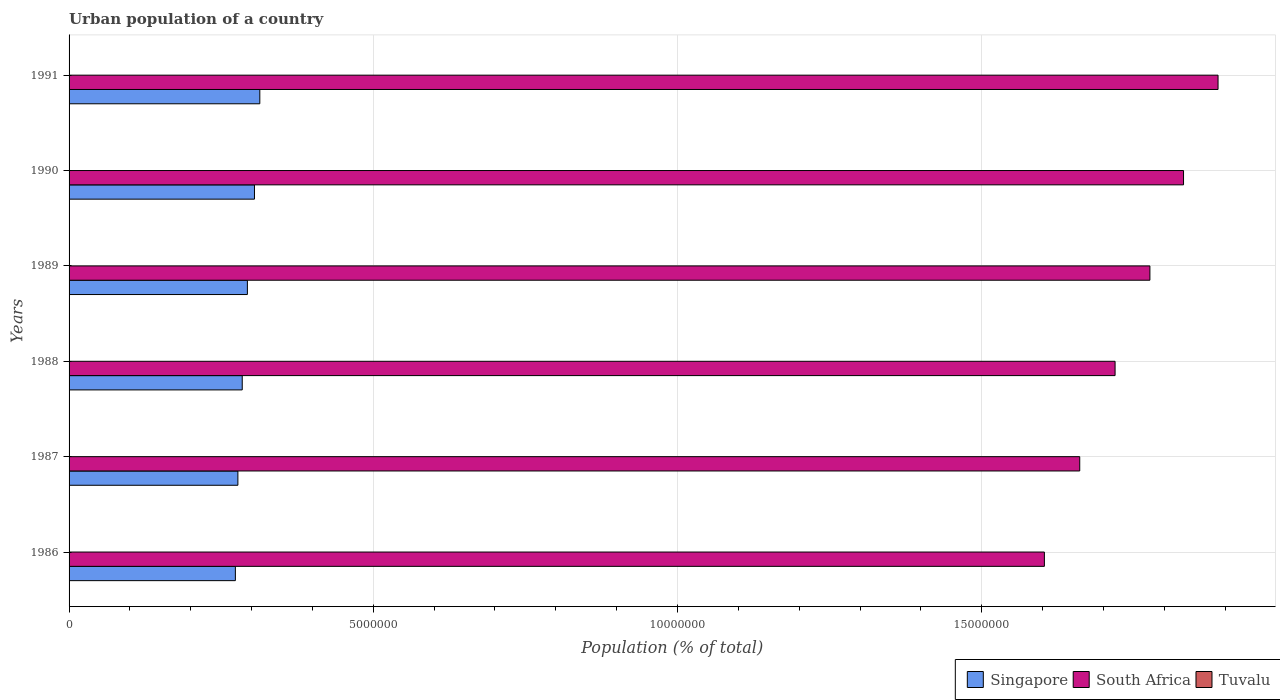How many different coloured bars are there?
Keep it short and to the point. 3. Are the number of bars per tick equal to the number of legend labels?
Keep it short and to the point. Yes. Are the number of bars on each tick of the Y-axis equal?
Your answer should be compact. Yes. How many bars are there on the 2nd tick from the top?
Ensure brevity in your answer.  3. What is the label of the 4th group of bars from the top?
Provide a succinct answer. 1988. In how many cases, is the number of bars for a given year not equal to the number of legend labels?
Give a very brief answer. 0. What is the urban population in South Africa in 1986?
Provide a short and direct response. 1.60e+07. Across all years, what is the maximum urban population in Tuvalu?
Keep it short and to the point. 3803. Across all years, what is the minimum urban population in Tuvalu?
Offer a very short reply. 3103. What is the total urban population in Singapore in the graph?
Provide a succinct answer. 1.75e+07. What is the difference between the urban population in Singapore in 1986 and that in 1987?
Keep it short and to the point. -4.14e+04. What is the difference between the urban population in Singapore in 1987 and the urban population in Tuvalu in 1989?
Provide a succinct answer. 2.77e+06. What is the average urban population in South Africa per year?
Your response must be concise. 1.75e+07. In the year 1986, what is the difference between the urban population in Tuvalu and urban population in South Africa?
Provide a succinct answer. -1.60e+07. What is the ratio of the urban population in South Africa in 1987 to that in 1991?
Give a very brief answer. 0.88. Is the difference between the urban population in Tuvalu in 1986 and 1990 greater than the difference between the urban population in South Africa in 1986 and 1990?
Provide a succinct answer. Yes. What is the difference between the highest and the second highest urban population in South Africa?
Give a very brief answer. 5.67e+05. What is the difference between the highest and the lowest urban population in Tuvalu?
Provide a short and direct response. 700. In how many years, is the urban population in South Africa greater than the average urban population in South Africa taken over all years?
Your answer should be very brief. 3. What does the 1st bar from the top in 1987 represents?
Ensure brevity in your answer.  Tuvalu. What does the 1st bar from the bottom in 1990 represents?
Offer a very short reply. Singapore. How many bars are there?
Ensure brevity in your answer.  18. How many years are there in the graph?
Provide a succinct answer. 6. What is the difference between two consecutive major ticks on the X-axis?
Provide a succinct answer. 5.00e+06. Are the values on the major ticks of X-axis written in scientific E-notation?
Give a very brief answer. No. Where does the legend appear in the graph?
Provide a short and direct response. Bottom right. How are the legend labels stacked?
Keep it short and to the point. Horizontal. What is the title of the graph?
Your response must be concise. Urban population of a country. What is the label or title of the X-axis?
Provide a short and direct response. Population (% of total). What is the Population (% of total) in Singapore in 1986?
Your answer should be compact. 2.73e+06. What is the Population (% of total) of South Africa in 1986?
Your answer should be very brief. 1.60e+07. What is the Population (% of total) of Tuvalu in 1986?
Give a very brief answer. 3103. What is the Population (% of total) of Singapore in 1987?
Provide a succinct answer. 2.77e+06. What is the Population (% of total) in South Africa in 1987?
Offer a very short reply. 1.66e+07. What is the Population (% of total) of Tuvalu in 1987?
Offer a very short reply. 3243. What is the Population (% of total) in Singapore in 1988?
Ensure brevity in your answer.  2.85e+06. What is the Population (% of total) in South Africa in 1988?
Give a very brief answer. 1.72e+07. What is the Population (% of total) in Tuvalu in 1988?
Your answer should be compact. 3382. What is the Population (% of total) in Singapore in 1989?
Keep it short and to the point. 2.93e+06. What is the Population (% of total) in South Africa in 1989?
Your response must be concise. 1.78e+07. What is the Population (% of total) in Tuvalu in 1989?
Ensure brevity in your answer.  3521. What is the Population (% of total) of Singapore in 1990?
Keep it short and to the point. 3.05e+06. What is the Population (% of total) of South Africa in 1990?
Provide a short and direct response. 1.83e+07. What is the Population (% of total) in Tuvalu in 1990?
Make the answer very short. 3661. What is the Population (% of total) of Singapore in 1991?
Keep it short and to the point. 3.14e+06. What is the Population (% of total) in South Africa in 1991?
Make the answer very short. 1.89e+07. What is the Population (% of total) in Tuvalu in 1991?
Provide a short and direct response. 3803. Across all years, what is the maximum Population (% of total) in Singapore?
Make the answer very short. 3.14e+06. Across all years, what is the maximum Population (% of total) in South Africa?
Provide a succinct answer. 1.89e+07. Across all years, what is the maximum Population (% of total) of Tuvalu?
Give a very brief answer. 3803. Across all years, what is the minimum Population (% of total) in Singapore?
Ensure brevity in your answer.  2.73e+06. Across all years, what is the minimum Population (% of total) of South Africa?
Ensure brevity in your answer.  1.60e+07. Across all years, what is the minimum Population (% of total) of Tuvalu?
Provide a short and direct response. 3103. What is the total Population (% of total) of Singapore in the graph?
Your answer should be very brief. 1.75e+07. What is the total Population (% of total) in South Africa in the graph?
Give a very brief answer. 1.05e+08. What is the total Population (% of total) in Tuvalu in the graph?
Your answer should be very brief. 2.07e+04. What is the difference between the Population (% of total) in Singapore in 1986 and that in 1987?
Provide a succinct answer. -4.14e+04. What is the difference between the Population (% of total) in South Africa in 1986 and that in 1987?
Give a very brief answer. -5.81e+05. What is the difference between the Population (% of total) of Tuvalu in 1986 and that in 1987?
Offer a terse response. -140. What is the difference between the Population (% of total) in Singapore in 1986 and that in 1988?
Make the answer very short. -1.13e+05. What is the difference between the Population (% of total) in South Africa in 1986 and that in 1988?
Your answer should be compact. -1.16e+06. What is the difference between the Population (% of total) of Tuvalu in 1986 and that in 1988?
Ensure brevity in your answer.  -279. What is the difference between the Population (% of total) in Singapore in 1986 and that in 1989?
Your answer should be compact. -1.98e+05. What is the difference between the Population (% of total) in South Africa in 1986 and that in 1989?
Ensure brevity in your answer.  -1.73e+06. What is the difference between the Population (% of total) of Tuvalu in 1986 and that in 1989?
Give a very brief answer. -418. What is the difference between the Population (% of total) of Singapore in 1986 and that in 1990?
Make the answer very short. -3.14e+05. What is the difference between the Population (% of total) of South Africa in 1986 and that in 1990?
Ensure brevity in your answer.  -2.29e+06. What is the difference between the Population (% of total) of Tuvalu in 1986 and that in 1990?
Your response must be concise. -558. What is the difference between the Population (% of total) in Singapore in 1986 and that in 1991?
Your answer should be compact. -4.02e+05. What is the difference between the Population (% of total) in South Africa in 1986 and that in 1991?
Your answer should be compact. -2.85e+06. What is the difference between the Population (% of total) of Tuvalu in 1986 and that in 1991?
Make the answer very short. -700. What is the difference between the Population (% of total) of Singapore in 1987 and that in 1988?
Provide a succinct answer. -7.13e+04. What is the difference between the Population (% of total) in South Africa in 1987 and that in 1988?
Provide a succinct answer. -5.81e+05. What is the difference between the Population (% of total) of Tuvalu in 1987 and that in 1988?
Provide a succinct answer. -139. What is the difference between the Population (% of total) in Singapore in 1987 and that in 1989?
Your answer should be very brief. -1.56e+05. What is the difference between the Population (% of total) of South Africa in 1987 and that in 1989?
Provide a succinct answer. -1.15e+06. What is the difference between the Population (% of total) of Tuvalu in 1987 and that in 1989?
Keep it short and to the point. -278. What is the difference between the Population (% of total) of Singapore in 1987 and that in 1990?
Give a very brief answer. -2.72e+05. What is the difference between the Population (% of total) of South Africa in 1987 and that in 1990?
Offer a terse response. -1.71e+06. What is the difference between the Population (% of total) of Tuvalu in 1987 and that in 1990?
Your answer should be compact. -418. What is the difference between the Population (% of total) in Singapore in 1987 and that in 1991?
Ensure brevity in your answer.  -3.60e+05. What is the difference between the Population (% of total) in South Africa in 1987 and that in 1991?
Ensure brevity in your answer.  -2.27e+06. What is the difference between the Population (% of total) in Tuvalu in 1987 and that in 1991?
Give a very brief answer. -560. What is the difference between the Population (% of total) of Singapore in 1988 and that in 1989?
Ensure brevity in your answer.  -8.48e+04. What is the difference between the Population (% of total) of South Africa in 1988 and that in 1989?
Provide a succinct answer. -5.72e+05. What is the difference between the Population (% of total) of Tuvalu in 1988 and that in 1989?
Offer a very short reply. -139. What is the difference between the Population (% of total) of Singapore in 1988 and that in 1990?
Offer a very short reply. -2.01e+05. What is the difference between the Population (% of total) in South Africa in 1988 and that in 1990?
Your answer should be compact. -1.12e+06. What is the difference between the Population (% of total) in Tuvalu in 1988 and that in 1990?
Give a very brief answer. -279. What is the difference between the Population (% of total) of Singapore in 1988 and that in 1991?
Offer a terse response. -2.89e+05. What is the difference between the Population (% of total) of South Africa in 1988 and that in 1991?
Your answer should be very brief. -1.69e+06. What is the difference between the Population (% of total) in Tuvalu in 1988 and that in 1991?
Offer a terse response. -421. What is the difference between the Population (% of total) in Singapore in 1989 and that in 1990?
Ensure brevity in your answer.  -1.16e+05. What is the difference between the Population (% of total) of South Africa in 1989 and that in 1990?
Provide a short and direct response. -5.53e+05. What is the difference between the Population (% of total) of Tuvalu in 1989 and that in 1990?
Provide a succinct answer. -140. What is the difference between the Population (% of total) of Singapore in 1989 and that in 1991?
Offer a terse response. -2.04e+05. What is the difference between the Population (% of total) of South Africa in 1989 and that in 1991?
Offer a very short reply. -1.12e+06. What is the difference between the Population (% of total) of Tuvalu in 1989 and that in 1991?
Ensure brevity in your answer.  -282. What is the difference between the Population (% of total) in Singapore in 1990 and that in 1991?
Your response must be concise. -8.80e+04. What is the difference between the Population (% of total) in South Africa in 1990 and that in 1991?
Keep it short and to the point. -5.67e+05. What is the difference between the Population (% of total) in Tuvalu in 1990 and that in 1991?
Your answer should be compact. -142. What is the difference between the Population (% of total) of Singapore in 1986 and the Population (% of total) of South Africa in 1987?
Provide a short and direct response. -1.39e+07. What is the difference between the Population (% of total) in Singapore in 1986 and the Population (% of total) in Tuvalu in 1987?
Provide a short and direct response. 2.73e+06. What is the difference between the Population (% of total) of South Africa in 1986 and the Population (% of total) of Tuvalu in 1987?
Your answer should be compact. 1.60e+07. What is the difference between the Population (% of total) of Singapore in 1986 and the Population (% of total) of South Africa in 1988?
Make the answer very short. -1.45e+07. What is the difference between the Population (% of total) of Singapore in 1986 and the Population (% of total) of Tuvalu in 1988?
Ensure brevity in your answer.  2.73e+06. What is the difference between the Population (% of total) of South Africa in 1986 and the Population (% of total) of Tuvalu in 1988?
Offer a terse response. 1.60e+07. What is the difference between the Population (% of total) of Singapore in 1986 and the Population (% of total) of South Africa in 1989?
Provide a short and direct response. -1.50e+07. What is the difference between the Population (% of total) of Singapore in 1986 and the Population (% of total) of Tuvalu in 1989?
Your answer should be compact. 2.73e+06. What is the difference between the Population (% of total) in South Africa in 1986 and the Population (% of total) in Tuvalu in 1989?
Give a very brief answer. 1.60e+07. What is the difference between the Population (% of total) in Singapore in 1986 and the Population (% of total) in South Africa in 1990?
Your response must be concise. -1.56e+07. What is the difference between the Population (% of total) in Singapore in 1986 and the Population (% of total) in Tuvalu in 1990?
Keep it short and to the point. 2.73e+06. What is the difference between the Population (% of total) of South Africa in 1986 and the Population (% of total) of Tuvalu in 1990?
Provide a succinct answer. 1.60e+07. What is the difference between the Population (% of total) in Singapore in 1986 and the Population (% of total) in South Africa in 1991?
Offer a very short reply. -1.62e+07. What is the difference between the Population (% of total) in Singapore in 1986 and the Population (% of total) in Tuvalu in 1991?
Provide a short and direct response. 2.73e+06. What is the difference between the Population (% of total) in South Africa in 1986 and the Population (% of total) in Tuvalu in 1991?
Offer a terse response. 1.60e+07. What is the difference between the Population (% of total) in Singapore in 1987 and the Population (% of total) in South Africa in 1988?
Give a very brief answer. -1.44e+07. What is the difference between the Population (% of total) of Singapore in 1987 and the Population (% of total) of Tuvalu in 1988?
Your answer should be very brief. 2.77e+06. What is the difference between the Population (% of total) of South Africa in 1987 and the Population (% of total) of Tuvalu in 1988?
Your response must be concise. 1.66e+07. What is the difference between the Population (% of total) in Singapore in 1987 and the Population (% of total) in South Africa in 1989?
Your answer should be compact. -1.50e+07. What is the difference between the Population (% of total) in Singapore in 1987 and the Population (% of total) in Tuvalu in 1989?
Offer a very short reply. 2.77e+06. What is the difference between the Population (% of total) in South Africa in 1987 and the Population (% of total) in Tuvalu in 1989?
Give a very brief answer. 1.66e+07. What is the difference between the Population (% of total) in Singapore in 1987 and the Population (% of total) in South Africa in 1990?
Provide a succinct answer. -1.55e+07. What is the difference between the Population (% of total) of Singapore in 1987 and the Population (% of total) of Tuvalu in 1990?
Your answer should be very brief. 2.77e+06. What is the difference between the Population (% of total) in South Africa in 1987 and the Population (% of total) in Tuvalu in 1990?
Ensure brevity in your answer.  1.66e+07. What is the difference between the Population (% of total) of Singapore in 1987 and the Population (% of total) of South Africa in 1991?
Offer a very short reply. -1.61e+07. What is the difference between the Population (% of total) of Singapore in 1987 and the Population (% of total) of Tuvalu in 1991?
Give a very brief answer. 2.77e+06. What is the difference between the Population (% of total) of South Africa in 1987 and the Population (% of total) of Tuvalu in 1991?
Offer a very short reply. 1.66e+07. What is the difference between the Population (% of total) in Singapore in 1988 and the Population (% of total) in South Africa in 1989?
Provide a short and direct response. -1.49e+07. What is the difference between the Population (% of total) of Singapore in 1988 and the Population (% of total) of Tuvalu in 1989?
Make the answer very short. 2.84e+06. What is the difference between the Population (% of total) in South Africa in 1988 and the Population (% of total) in Tuvalu in 1989?
Provide a succinct answer. 1.72e+07. What is the difference between the Population (% of total) of Singapore in 1988 and the Population (% of total) of South Africa in 1990?
Your answer should be very brief. -1.55e+07. What is the difference between the Population (% of total) of Singapore in 1988 and the Population (% of total) of Tuvalu in 1990?
Provide a short and direct response. 2.84e+06. What is the difference between the Population (% of total) in South Africa in 1988 and the Population (% of total) in Tuvalu in 1990?
Provide a short and direct response. 1.72e+07. What is the difference between the Population (% of total) in Singapore in 1988 and the Population (% of total) in South Africa in 1991?
Offer a very short reply. -1.60e+07. What is the difference between the Population (% of total) of Singapore in 1988 and the Population (% of total) of Tuvalu in 1991?
Your answer should be very brief. 2.84e+06. What is the difference between the Population (% of total) in South Africa in 1988 and the Population (% of total) in Tuvalu in 1991?
Keep it short and to the point. 1.72e+07. What is the difference between the Population (% of total) in Singapore in 1989 and the Population (% of total) in South Africa in 1990?
Your response must be concise. -1.54e+07. What is the difference between the Population (% of total) of Singapore in 1989 and the Population (% of total) of Tuvalu in 1990?
Provide a short and direct response. 2.93e+06. What is the difference between the Population (% of total) of South Africa in 1989 and the Population (% of total) of Tuvalu in 1990?
Make the answer very short. 1.78e+07. What is the difference between the Population (% of total) in Singapore in 1989 and the Population (% of total) in South Africa in 1991?
Provide a short and direct response. -1.60e+07. What is the difference between the Population (% of total) in Singapore in 1989 and the Population (% of total) in Tuvalu in 1991?
Give a very brief answer. 2.93e+06. What is the difference between the Population (% of total) in South Africa in 1989 and the Population (% of total) in Tuvalu in 1991?
Your answer should be compact. 1.78e+07. What is the difference between the Population (% of total) in Singapore in 1990 and the Population (% of total) in South Africa in 1991?
Provide a succinct answer. -1.58e+07. What is the difference between the Population (% of total) in Singapore in 1990 and the Population (% of total) in Tuvalu in 1991?
Offer a terse response. 3.04e+06. What is the difference between the Population (% of total) in South Africa in 1990 and the Population (% of total) in Tuvalu in 1991?
Offer a very short reply. 1.83e+07. What is the average Population (% of total) in Singapore per year?
Your response must be concise. 2.91e+06. What is the average Population (% of total) of South Africa per year?
Offer a terse response. 1.75e+07. What is the average Population (% of total) of Tuvalu per year?
Offer a very short reply. 3452.17. In the year 1986, what is the difference between the Population (% of total) of Singapore and Population (% of total) of South Africa?
Your response must be concise. -1.33e+07. In the year 1986, what is the difference between the Population (% of total) of Singapore and Population (% of total) of Tuvalu?
Provide a short and direct response. 2.73e+06. In the year 1986, what is the difference between the Population (% of total) in South Africa and Population (% of total) in Tuvalu?
Your answer should be very brief. 1.60e+07. In the year 1987, what is the difference between the Population (% of total) in Singapore and Population (% of total) in South Africa?
Your answer should be very brief. -1.38e+07. In the year 1987, what is the difference between the Population (% of total) in Singapore and Population (% of total) in Tuvalu?
Offer a very short reply. 2.77e+06. In the year 1987, what is the difference between the Population (% of total) of South Africa and Population (% of total) of Tuvalu?
Ensure brevity in your answer.  1.66e+07. In the year 1988, what is the difference between the Population (% of total) of Singapore and Population (% of total) of South Africa?
Offer a very short reply. -1.43e+07. In the year 1988, what is the difference between the Population (% of total) of Singapore and Population (% of total) of Tuvalu?
Offer a terse response. 2.84e+06. In the year 1988, what is the difference between the Population (% of total) of South Africa and Population (% of total) of Tuvalu?
Offer a terse response. 1.72e+07. In the year 1989, what is the difference between the Population (% of total) of Singapore and Population (% of total) of South Africa?
Ensure brevity in your answer.  -1.48e+07. In the year 1989, what is the difference between the Population (% of total) of Singapore and Population (% of total) of Tuvalu?
Provide a succinct answer. 2.93e+06. In the year 1989, what is the difference between the Population (% of total) of South Africa and Population (% of total) of Tuvalu?
Keep it short and to the point. 1.78e+07. In the year 1990, what is the difference between the Population (% of total) in Singapore and Population (% of total) in South Africa?
Ensure brevity in your answer.  -1.53e+07. In the year 1990, what is the difference between the Population (% of total) in Singapore and Population (% of total) in Tuvalu?
Keep it short and to the point. 3.04e+06. In the year 1990, what is the difference between the Population (% of total) in South Africa and Population (% of total) in Tuvalu?
Ensure brevity in your answer.  1.83e+07. In the year 1991, what is the difference between the Population (% of total) in Singapore and Population (% of total) in South Africa?
Provide a succinct answer. -1.57e+07. In the year 1991, what is the difference between the Population (% of total) in Singapore and Population (% of total) in Tuvalu?
Give a very brief answer. 3.13e+06. In the year 1991, what is the difference between the Population (% of total) in South Africa and Population (% of total) in Tuvalu?
Your answer should be compact. 1.89e+07. What is the ratio of the Population (% of total) of Singapore in 1986 to that in 1987?
Give a very brief answer. 0.99. What is the ratio of the Population (% of total) in Tuvalu in 1986 to that in 1987?
Make the answer very short. 0.96. What is the ratio of the Population (% of total) of Singapore in 1986 to that in 1988?
Offer a very short reply. 0.96. What is the ratio of the Population (% of total) in South Africa in 1986 to that in 1988?
Give a very brief answer. 0.93. What is the ratio of the Population (% of total) of Tuvalu in 1986 to that in 1988?
Provide a succinct answer. 0.92. What is the ratio of the Population (% of total) in Singapore in 1986 to that in 1989?
Keep it short and to the point. 0.93. What is the ratio of the Population (% of total) in South Africa in 1986 to that in 1989?
Your response must be concise. 0.9. What is the ratio of the Population (% of total) in Tuvalu in 1986 to that in 1989?
Your response must be concise. 0.88. What is the ratio of the Population (% of total) of Singapore in 1986 to that in 1990?
Offer a very short reply. 0.9. What is the ratio of the Population (% of total) of South Africa in 1986 to that in 1990?
Give a very brief answer. 0.88. What is the ratio of the Population (% of total) of Tuvalu in 1986 to that in 1990?
Ensure brevity in your answer.  0.85. What is the ratio of the Population (% of total) of Singapore in 1986 to that in 1991?
Offer a very short reply. 0.87. What is the ratio of the Population (% of total) in South Africa in 1986 to that in 1991?
Offer a very short reply. 0.85. What is the ratio of the Population (% of total) in Tuvalu in 1986 to that in 1991?
Provide a succinct answer. 0.82. What is the ratio of the Population (% of total) of Singapore in 1987 to that in 1988?
Provide a succinct answer. 0.97. What is the ratio of the Population (% of total) of South Africa in 1987 to that in 1988?
Your answer should be very brief. 0.97. What is the ratio of the Population (% of total) in Tuvalu in 1987 to that in 1988?
Your response must be concise. 0.96. What is the ratio of the Population (% of total) in Singapore in 1987 to that in 1989?
Make the answer very short. 0.95. What is the ratio of the Population (% of total) in South Africa in 1987 to that in 1989?
Offer a very short reply. 0.94. What is the ratio of the Population (% of total) in Tuvalu in 1987 to that in 1989?
Make the answer very short. 0.92. What is the ratio of the Population (% of total) in Singapore in 1987 to that in 1990?
Provide a succinct answer. 0.91. What is the ratio of the Population (% of total) of South Africa in 1987 to that in 1990?
Keep it short and to the point. 0.91. What is the ratio of the Population (% of total) in Tuvalu in 1987 to that in 1990?
Provide a succinct answer. 0.89. What is the ratio of the Population (% of total) in Singapore in 1987 to that in 1991?
Your answer should be very brief. 0.89. What is the ratio of the Population (% of total) in South Africa in 1987 to that in 1991?
Provide a succinct answer. 0.88. What is the ratio of the Population (% of total) in Tuvalu in 1987 to that in 1991?
Your answer should be very brief. 0.85. What is the ratio of the Population (% of total) in Singapore in 1988 to that in 1989?
Provide a short and direct response. 0.97. What is the ratio of the Population (% of total) of South Africa in 1988 to that in 1989?
Your answer should be very brief. 0.97. What is the ratio of the Population (% of total) of Tuvalu in 1988 to that in 1989?
Give a very brief answer. 0.96. What is the ratio of the Population (% of total) in Singapore in 1988 to that in 1990?
Your answer should be very brief. 0.93. What is the ratio of the Population (% of total) of South Africa in 1988 to that in 1990?
Provide a succinct answer. 0.94. What is the ratio of the Population (% of total) of Tuvalu in 1988 to that in 1990?
Give a very brief answer. 0.92. What is the ratio of the Population (% of total) in Singapore in 1988 to that in 1991?
Your response must be concise. 0.91. What is the ratio of the Population (% of total) in South Africa in 1988 to that in 1991?
Provide a succinct answer. 0.91. What is the ratio of the Population (% of total) in Tuvalu in 1988 to that in 1991?
Keep it short and to the point. 0.89. What is the ratio of the Population (% of total) of Singapore in 1989 to that in 1990?
Provide a short and direct response. 0.96. What is the ratio of the Population (% of total) in South Africa in 1989 to that in 1990?
Give a very brief answer. 0.97. What is the ratio of the Population (% of total) in Tuvalu in 1989 to that in 1990?
Ensure brevity in your answer.  0.96. What is the ratio of the Population (% of total) of Singapore in 1989 to that in 1991?
Make the answer very short. 0.93. What is the ratio of the Population (% of total) in South Africa in 1989 to that in 1991?
Ensure brevity in your answer.  0.94. What is the ratio of the Population (% of total) of Tuvalu in 1989 to that in 1991?
Make the answer very short. 0.93. What is the ratio of the Population (% of total) in Singapore in 1990 to that in 1991?
Your answer should be very brief. 0.97. What is the ratio of the Population (% of total) of Tuvalu in 1990 to that in 1991?
Your answer should be compact. 0.96. What is the difference between the highest and the second highest Population (% of total) of Singapore?
Give a very brief answer. 8.80e+04. What is the difference between the highest and the second highest Population (% of total) in South Africa?
Your answer should be very brief. 5.67e+05. What is the difference between the highest and the second highest Population (% of total) in Tuvalu?
Provide a succinct answer. 142. What is the difference between the highest and the lowest Population (% of total) in Singapore?
Ensure brevity in your answer.  4.02e+05. What is the difference between the highest and the lowest Population (% of total) of South Africa?
Give a very brief answer. 2.85e+06. What is the difference between the highest and the lowest Population (% of total) in Tuvalu?
Offer a terse response. 700. 